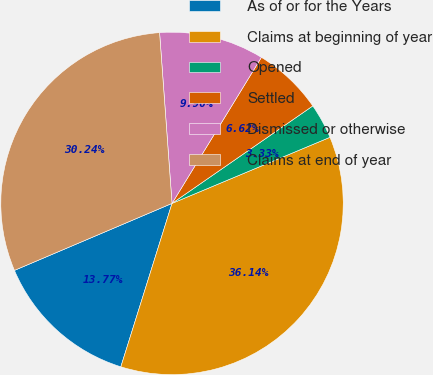<chart> <loc_0><loc_0><loc_500><loc_500><pie_chart><fcel>As of or for the Years<fcel>Claims at beginning of year<fcel>Opened<fcel>Settled<fcel>Dismissed or otherwise<fcel>Claims at end of year<nl><fcel>13.77%<fcel>36.14%<fcel>3.33%<fcel>6.62%<fcel>9.9%<fcel>30.24%<nl></chart> 